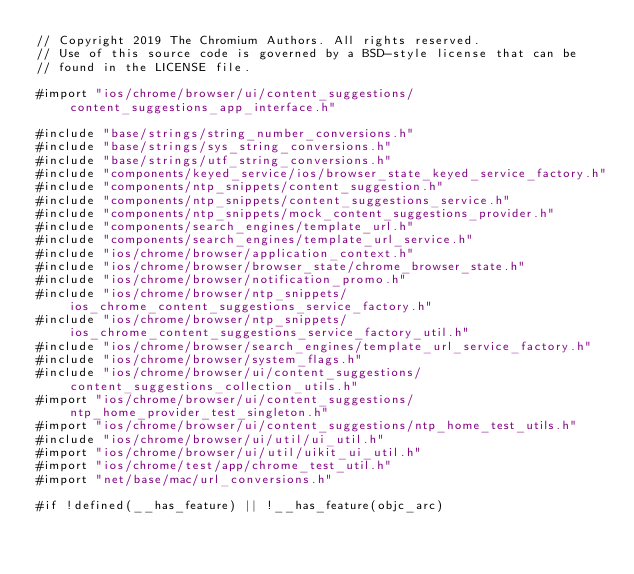<code> <loc_0><loc_0><loc_500><loc_500><_ObjectiveC_>// Copyright 2019 The Chromium Authors. All rights reserved.
// Use of this source code is governed by a BSD-style license that can be
// found in the LICENSE file.

#import "ios/chrome/browser/ui/content_suggestions/content_suggestions_app_interface.h"

#include "base/strings/string_number_conversions.h"
#include "base/strings/sys_string_conversions.h"
#include "base/strings/utf_string_conversions.h"
#include "components/keyed_service/ios/browser_state_keyed_service_factory.h"
#include "components/ntp_snippets/content_suggestion.h"
#include "components/ntp_snippets/content_suggestions_service.h"
#include "components/ntp_snippets/mock_content_suggestions_provider.h"
#include "components/search_engines/template_url.h"
#include "components/search_engines/template_url_service.h"
#include "ios/chrome/browser/application_context.h"
#include "ios/chrome/browser/browser_state/chrome_browser_state.h"
#include "ios/chrome/browser/notification_promo.h"
#include "ios/chrome/browser/ntp_snippets/ios_chrome_content_suggestions_service_factory.h"
#include "ios/chrome/browser/ntp_snippets/ios_chrome_content_suggestions_service_factory_util.h"
#include "ios/chrome/browser/search_engines/template_url_service_factory.h"
#include "ios/chrome/browser/system_flags.h"
#include "ios/chrome/browser/ui/content_suggestions/content_suggestions_collection_utils.h"
#import "ios/chrome/browser/ui/content_suggestions/ntp_home_provider_test_singleton.h"
#import "ios/chrome/browser/ui/content_suggestions/ntp_home_test_utils.h"
#include "ios/chrome/browser/ui/util/ui_util.h"
#import "ios/chrome/browser/ui/util/uikit_ui_util.h"
#import "ios/chrome/test/app/chrome_test_util.h"
#import "net/base/mac/url_conversions.h"

#if !defined(__has_feature) || !__has_feature(objc_arc)</code> 